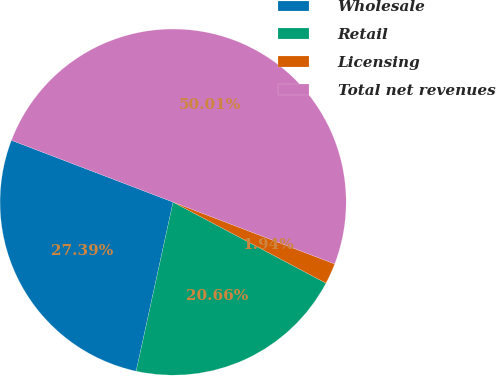Convert chart. <chart><loc_0><loc_0><loc_500><loc_500><pie_chart><fcel>Wholesale<fcel>Retail<fcel>Licensing<fcel>Total net revenues<nl><fcel>27.39%<fcel>20.66%<fcel>1.94%<fcel>50.0%<nl></chart> 